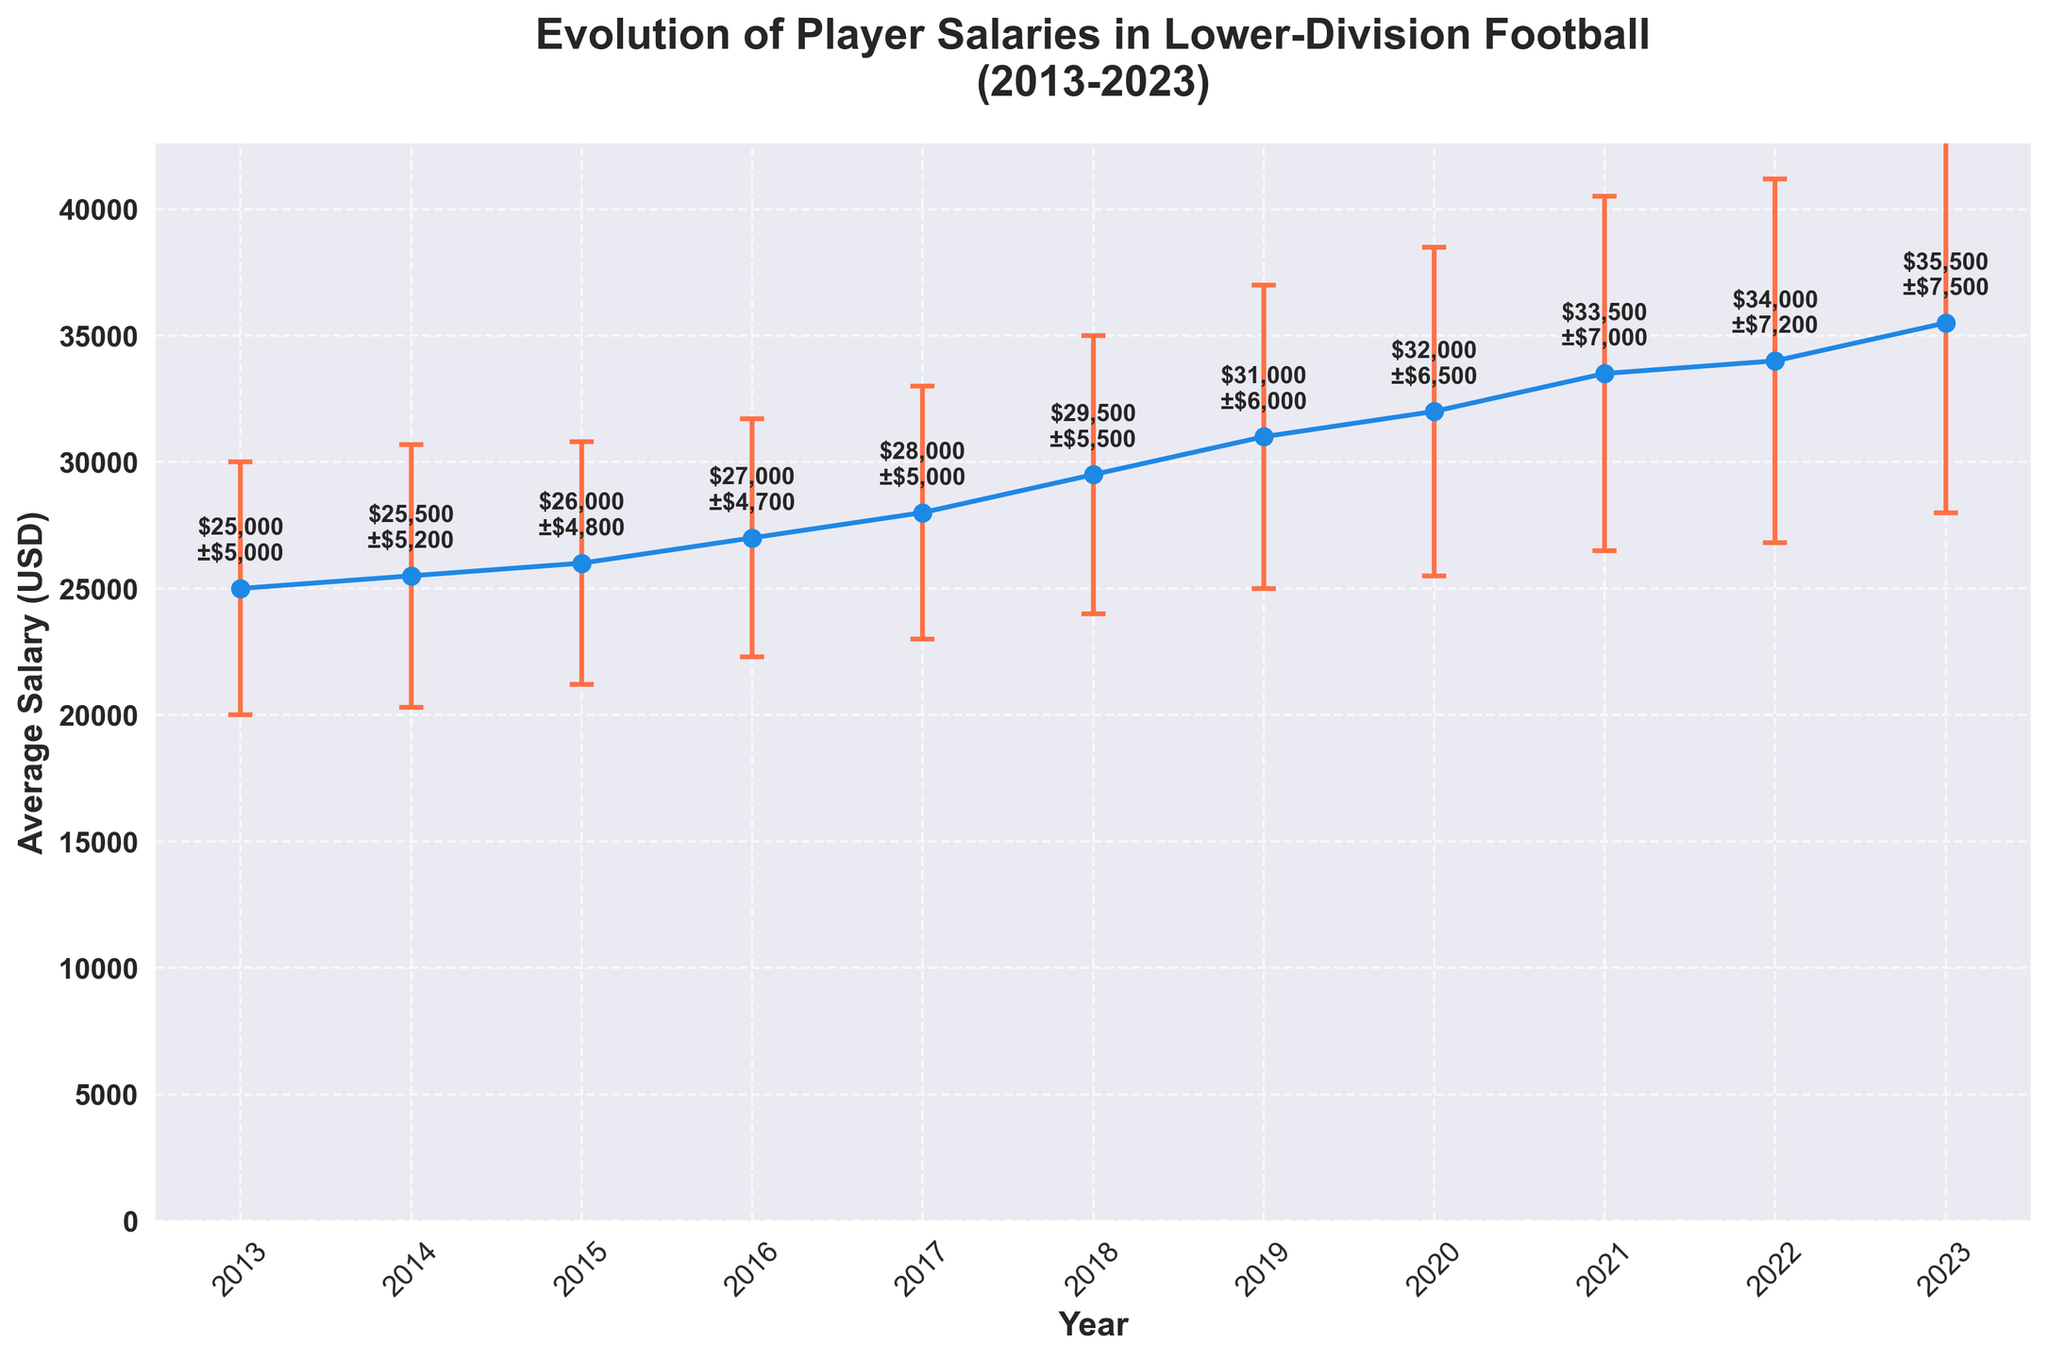What's the title of the plot? The title is usually displayed at the top of a figure to provide a summary of what the plot represents. In this case, it specifies the main subject and timeframe. The title reads: "Evolution of Player Salaries in Lower-Division Football (2013-2023)"
Answer: Evolution of Player Salaries in Lower-Division Football (2013-2023) What is the average salary in 2018? To find this, locate the point corresponding to the year 2018 on the x-axis and read the associated value on the y-axis. In this case, the average salary is marked next to the point for 2018. It is $29,500.
Answer: $29,500 What is the trend in player salaries from 2013 to 2023? To determine this, observe the overall direction of the line connecting the points from 2013 to 2023. From 2013 ($25,000) to 2023 ($35,500), the line shows a consistent upward trend, indicating that player salaries have been increasing over this period.
Answer: Increasing In which year is the variability in player salaries the highest? Variability is represented by the length of the error bars. The longest error bar indicates the highest variability. From the plot, the year 2023 has the longest error bar with a standard deviation of $7,500.
Answer: 2023 What is the increase in average salary from 2013 to 2023? To calculate the increase, subtract the average salary in 2013 from that in 2023: $35,500 - $25,000. This gives the difference as $10,500.
Answer: $10,500 Which year had an average salary of $27,000? To find the year, locate the point with an average salary of $27,000 on the y-axis and trace it horizontally to the corresponding year on the x-axis. In this plot, 2016 had an average salary of $27,000.
Answer: 2016 What is the average annual increase in salary over the decade? First, calculate the total increase over the decade: $35,500 (2023) - $25,000 (2013) = $10,500. Then, divide by the number of years (2023-2013 = 10): $10,500 / 10 = $1,050 per year.
Answer: $1,050 per year Between which consecutive years did the average salary increase the most? Compare salary differences between consecutive years by subtracting adjacent values. The largest increase is between 2017 ($28,000) and 2018 ($29,500), which is $1,500.
Answer: 2017 and 2018 Is there any year where the average salary did not increase compared to the previous year? To find this, observe the values year by year to see if any value remains the same or decreases. Over the entire span from 2013 to 2023, average salaries have increased each year without any stagnation or decrease.
Answer: No 